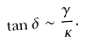<formula> <loc_0><loc_0><loc_500><loc_500>\tan \delta \sim \frac { \gamma } { \kappa } .</formula> 